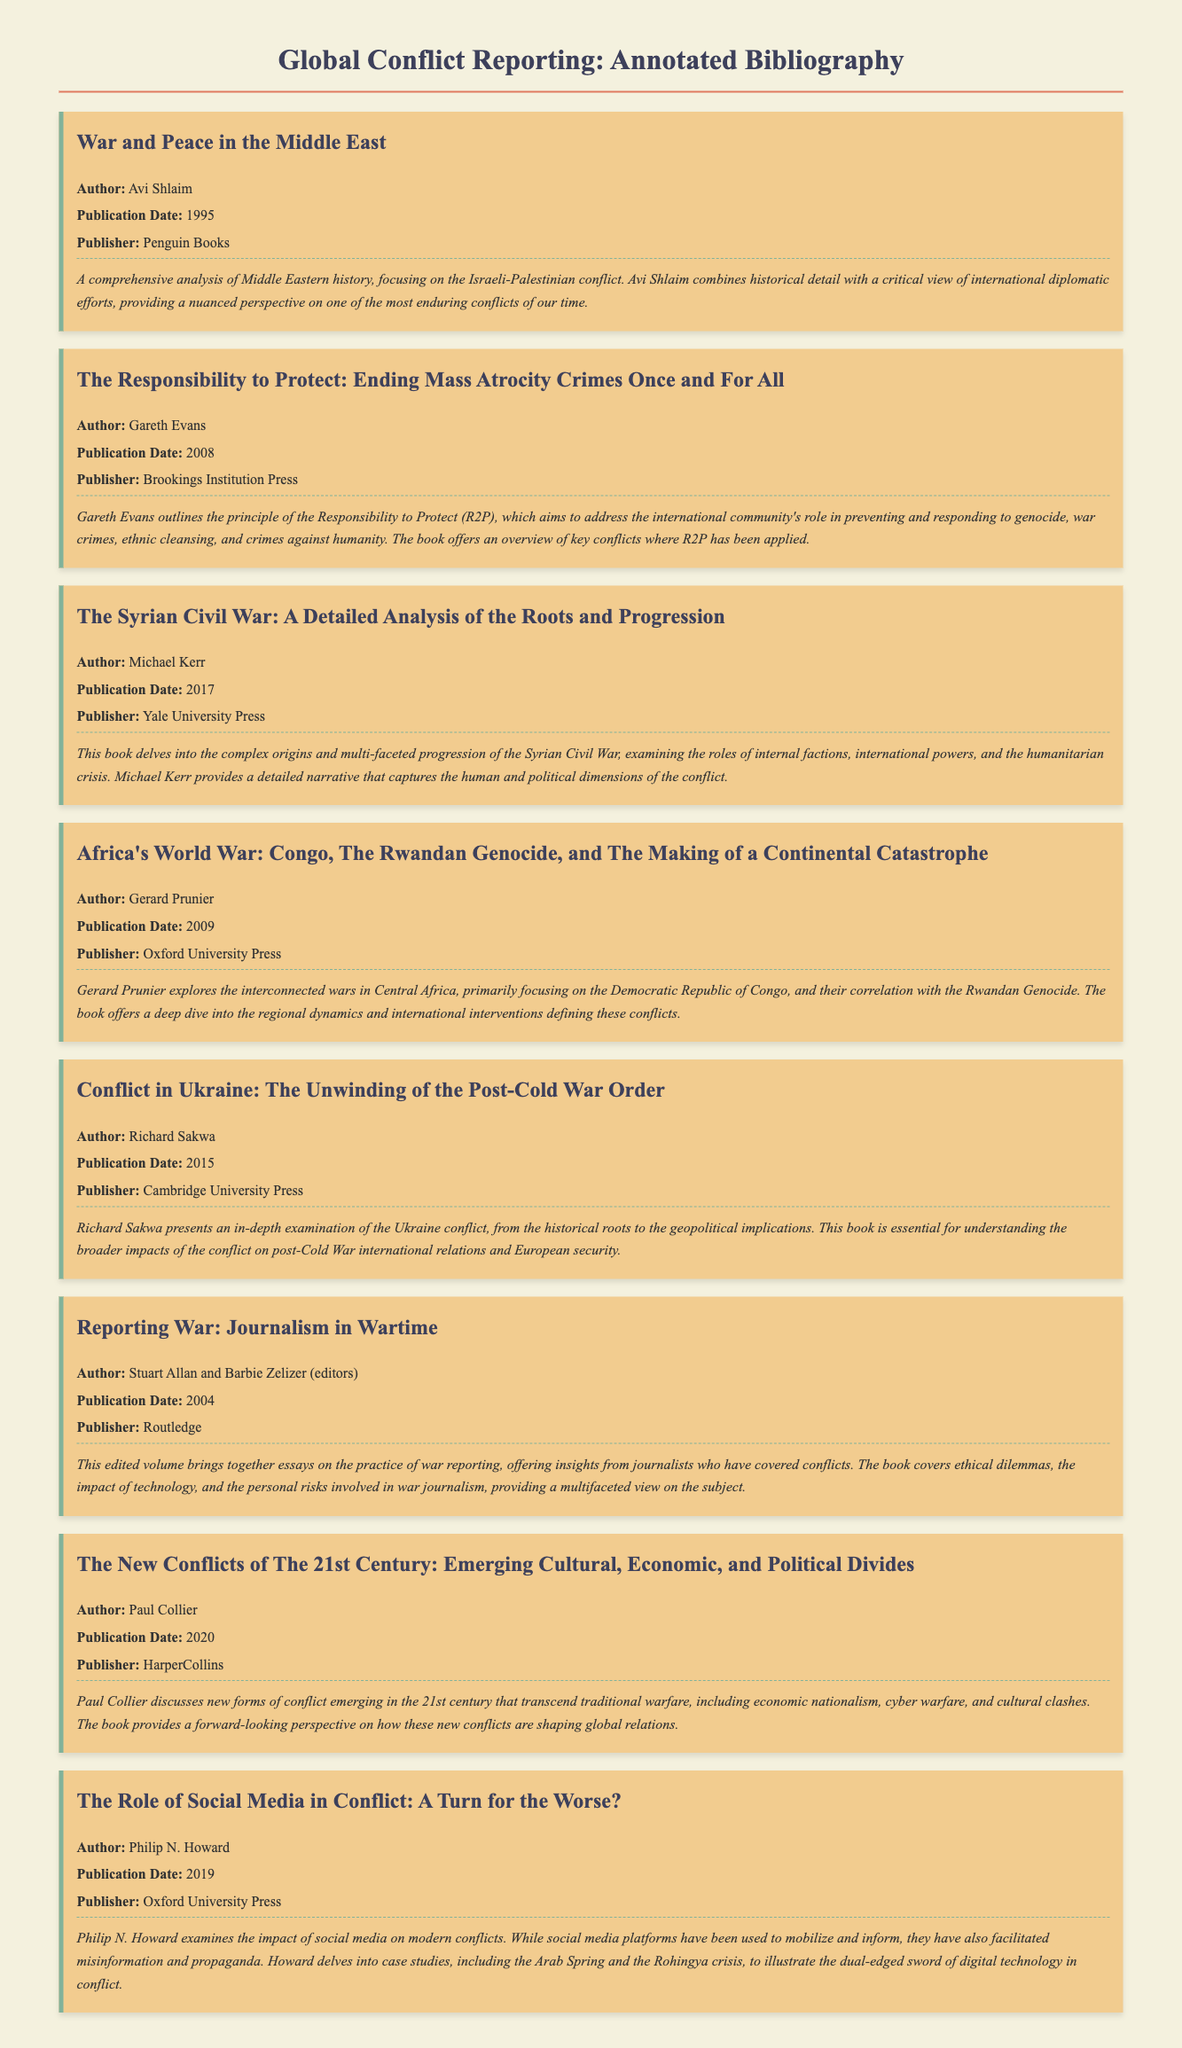What is the title of the first item? The title of the first item is found at the top of its corresponding section in the bibliography.
Answer: War and Peace in the Middle East Who is the author of "The Responsibility to Protect"? The author is listed directly underneath the title of the respective bibliography entry.
Answer: Gareth Evans What year was "Africa's World War" published? The publication date is clearly stated next to the author's name for each item.
Answer: 2009 Which publisher published "The Syrian Civil War"? The publisher's name is mentioned in the bibliography entry, typically following the publication date.
Answer: Yale University Press What concept does Gareth Evans discuss in his book? The abstract mentions the main topic or theme covered in the book.
Answer: Responsibility to Protect (R2P) How many bibliographic items are listed in total? The total number of entries can be counted from the document.
Answer: 8 What is a key conflict examined in "Conflict in Ukraine"? The abstracts provide insights into the major topics or conflicts discussed in each book.
Answer: Ukraine conflict Which editors contributed to "Reporting War"? The names of the editors are listed immediately after the title of the bibliography entry.
Answer: Stuart Allan and Barbie Zelizer 